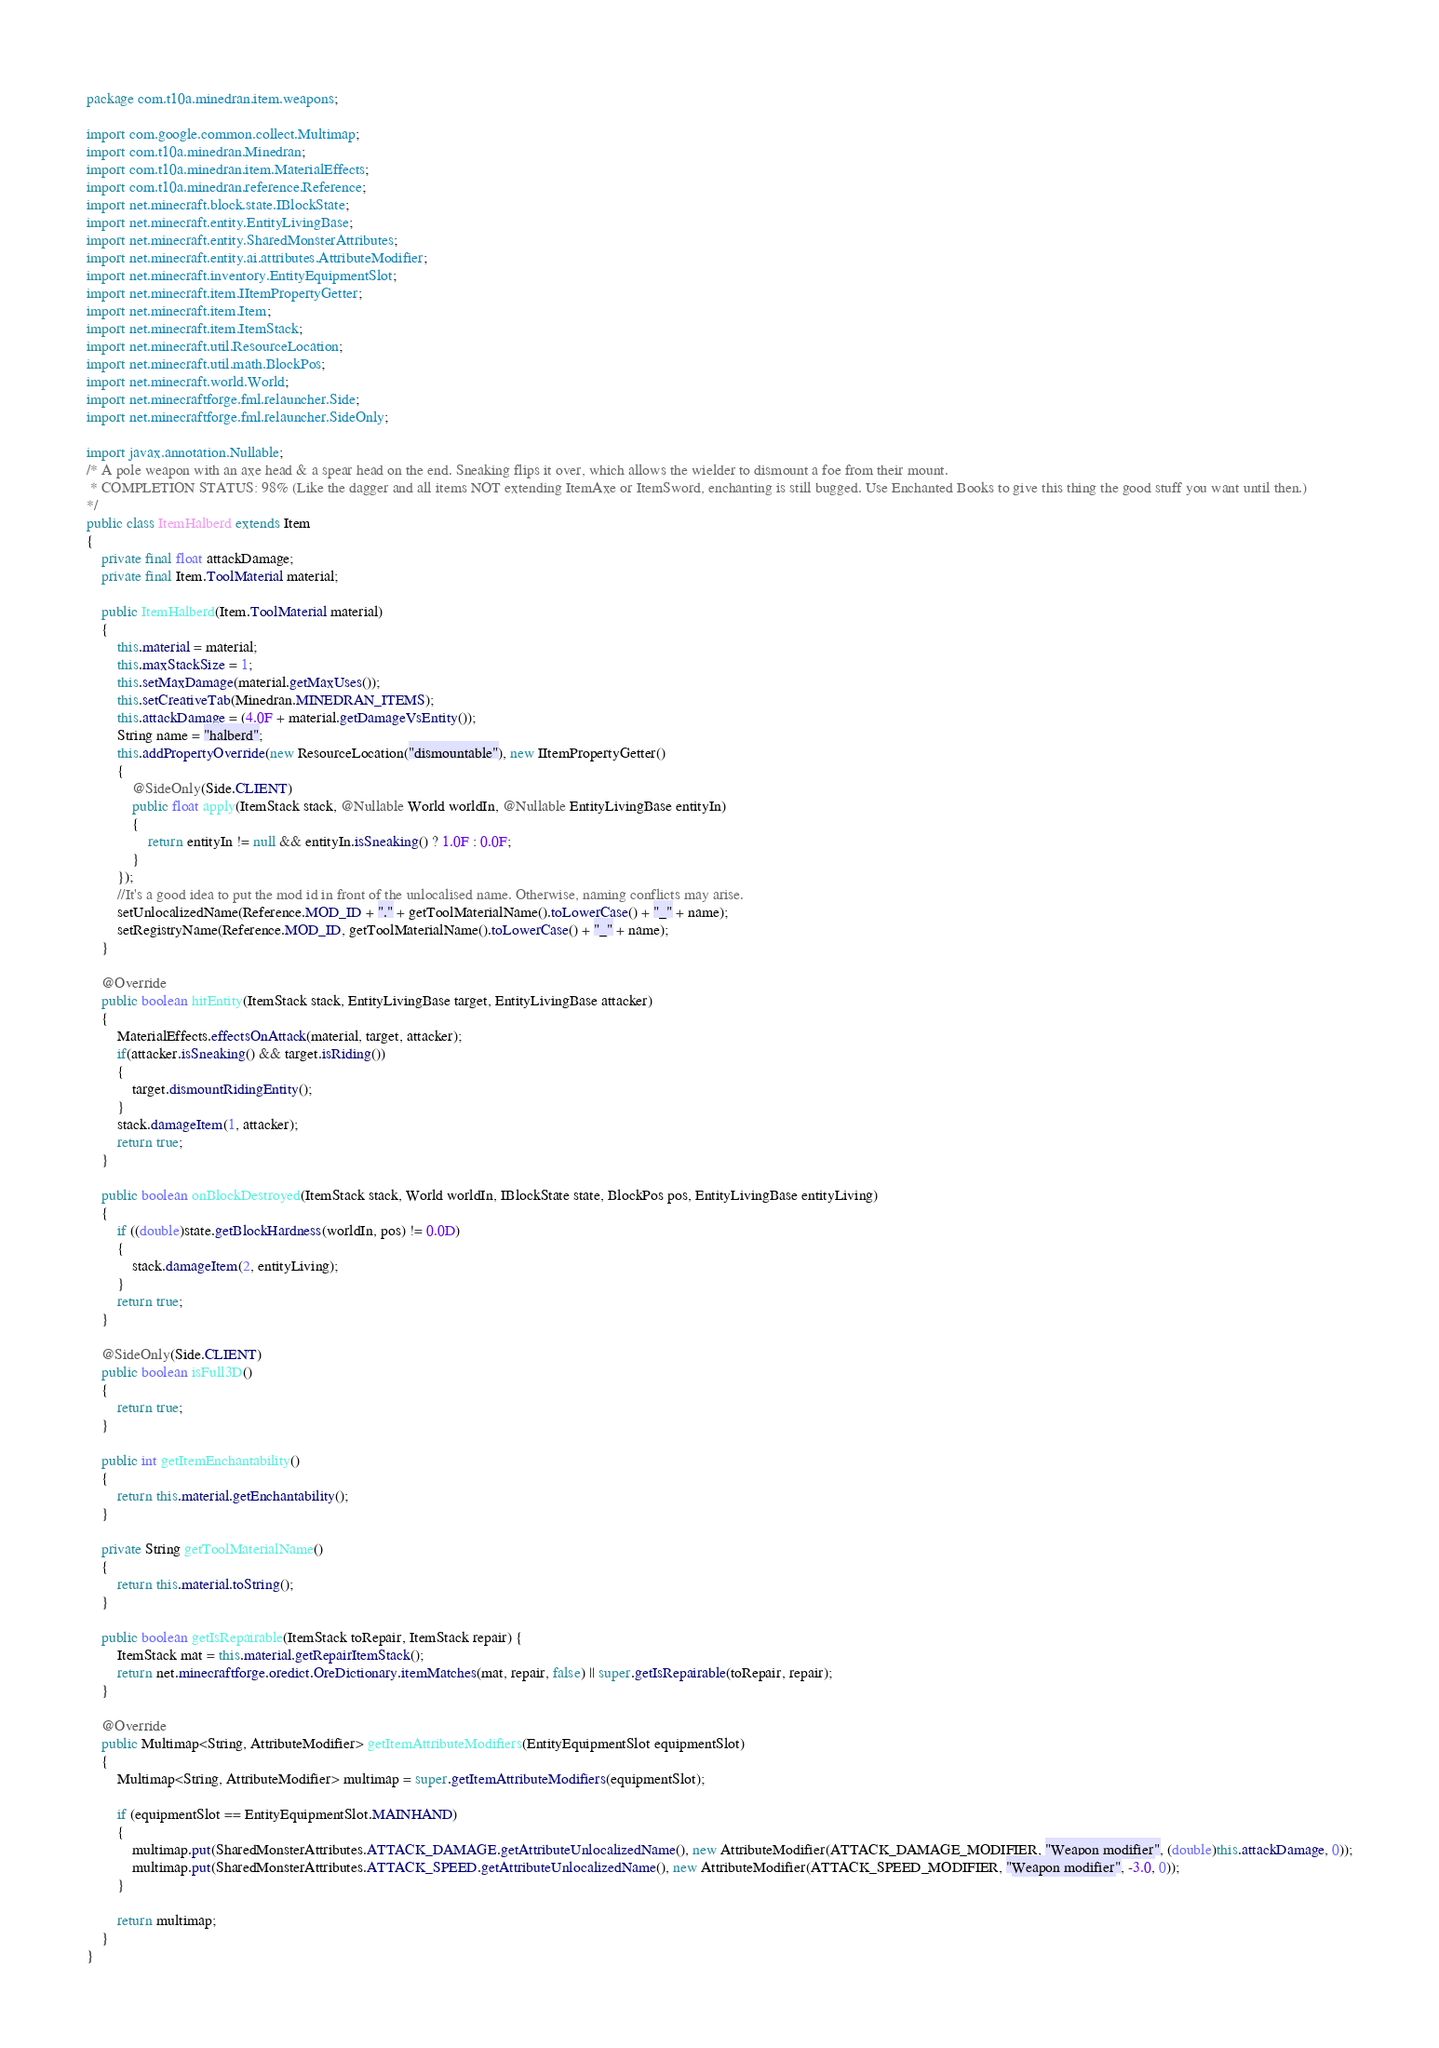Convert code to text. <code><loc_0><loc_0><loc_500><loc_500><_Java_>package com.t10a.minedran.item.weapons;

import com.google.common.collect.Multimap;
import com.t10a.minedran.Minedran;
import com.t10a.minedran.item.MaterialEffects;
import com.t10a.minedran.reference.Reference;
import net.minecraft.block.state.IBlockState;
import net.minecraft.entity.EntityLivingBase;
import net.minecraft.entity.SharedMonsterAttributes;
import net.minecraft.entity.ai.attributes.AttributeModifier;
import net.minecraft.inventory.EntityEquipmentSlot;
import net.minecraft.item.IItemPropertyGetter;
import net.minecraft.item.Item;
import net.minecraft.item.ItemStack;
import net.minecraft.util.ResourceLocation;
import net.minecraft.util.math.BlockPos;
import net.minecraft.world.World;
import net.minecraftforge.fml.relauncher.Side;
import net.minecraftforge.fml.relauncher.SideOnly;

import javax.annotation.Nullable;
/* A pole weapon with an axe head & a spear head on the end. Sneaking flips it over, which allows the wielder to dismount a foe from their mount.
 * COMPLETION STATUS: 98% (Like the dagger and all items NOT extending ItemAxe or ItemSword, enchanting is still bugged. Use Enchanted Books to give this thing the good stuff you want until then.)
*/
public class ItemHalberd extends Item
{
    private final float attackDamage;
    private final Item.ToolMaterial material;

    public ItemHalberd(Item.ToolMaterial material)
    {
        this.material = material;
        this.maxStackSize = 1;
        this.setMaxDamage(material.getMaxUses());
        this.setCreativeTab(Minedran.MINEDRAN_ITEMS);
        this.attackDamage = (4.0F + material.getDamageVsEntity());
        String name = "halberd";
        this.addPropertyOverride(new ResourceLocation("dismountable"), new IItemPropertyGetter()
        {
            @SideOnly(Side.CLIENT)
            public float apply(ItemStack stack, @Nullable World worldIn, @Nullable EntityLivingBase entityIn)
            {
                return entityIn != null && entityIn.isSneaking() ? 1.0F : 0.0F;
            }
        });
        //It's a good idea to put the mod id in front of the unlocalised name. Otherwise, naming conflicts may arise.
        setUnlocalizedName(Reference.MOD_ID + "." + getToolMaterialName().toLowerCase() + "_" + name);
        setRegistryName(Reference.MOD_ID, getToolMaterialName().toLowerCase() + "_" + name);
    }

    @Override
    public boolean hitEntity(ItemStack stack, EntityLivingBase target, EntityLivingBase attacker)
    {
        MaterialEffects.effectsOnAttack(material, target, attacker);
        if(attacker.isSneaking() && target.isRiding())
        {
            target.dismountRidingEntity();
        }
        stack.damageItem(1, attacker);
        return true;
    }

    public boolean onBlockDestroyed(ItemStack stack, World worldIn, IBlockState state, BlockPos pos, EntityLivingBase entityLiving)
    {
        if ((double)state.getBlockHardness(worldIn, pos) != 0.0D)
        {
            stack.damageItem(2, entityLiving);
        }
        return true;
    }

    @SideOnly(Side.CLIENT)
    public boolean isFull3D()
    {
        return true;
    }

    public int getItemEnchantability()
    {
        return this.material.getEnchantability();
    }

    private String getToolMaterialName()
    {
        return this.material.toString();
    }

    public boolean getIsRepairable(ItemStack toRepair, ItemStack repair) {
        ItemStack mat = this.material.getRepairItemStack();
        return net.minecraftforge.oredict.OreDictionary.itemMatches(mat, repair, false) || super.getIsRepairable(toRepair, repair);
    }

    @Override
    public Multimap<String, AttributeModifier> getItemAttributeModifiers(EntityEquipmentSlot equipmentSlot)
    {
        Multimap<String, AttributeModifier> multimap = super.getItemAttributeModifiers(equipmentSlot);

        if (equipmentSlot == EntityEquipmentSlot.MAINHAND)
        {
            multimap.put(SharedMonsterAttributes.ATTACK_DAMAGE.getAttributeUnlocalizedName(), new AttributeModifier(ATTACK_DAMAGE_MODIFIER, "Weapon modifier", (double)this.attackDamage, 0));
            multimap.put(SharedMonsterAttributes.ATTACK_SPEED.getAttributeUnlocalizedName(), new AttributeModifier(ATTACK_SPEED_MODIFIER, "Weapon modifier", -3.0, 0));
        }

        return multimap;
    }
}
</code> 